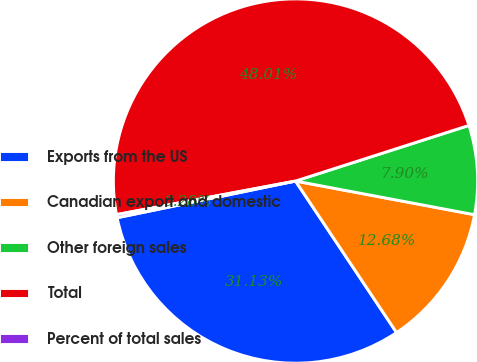<chart> <loc_0><loc_0><loc_500><loc_500><pie_chart><fcel>Exports from the US<fcel>Canadian export and domestic<fcel>Other foreign sales<fcel>Total<fcel>Percent of total sales<nl><fcel>31.13%<fcel>12.68%<fcel>7.9%<fcel>48.01%<fcel>0.28%<nl></chart> 